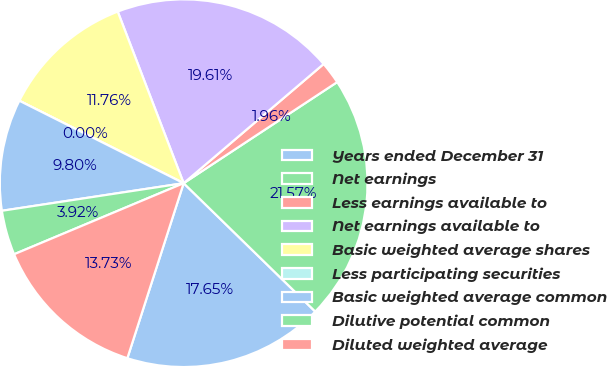Convert chart. <chart><loc_0><loc_0><loc_500><loc_500><pie_chart><fcel>Years ended December 31<fcel>Net earnings<fcel>Less earnings available to<fcel>Net earnings available to<fcel>Basic weighted average shares<fcel>Less participating securities<fcel>Basic weighted average common<fcel>Dilutive potential common<fcel>Diluted weighted average<nl><fcel>17.65%<fcel>21.57%<fcel>1.96%<fcel>19.61%<fcel>11.76%<fcel>0.0%<fcel>9.8%<fcel>3.92%<fcel>13.73%<nl></chart> 